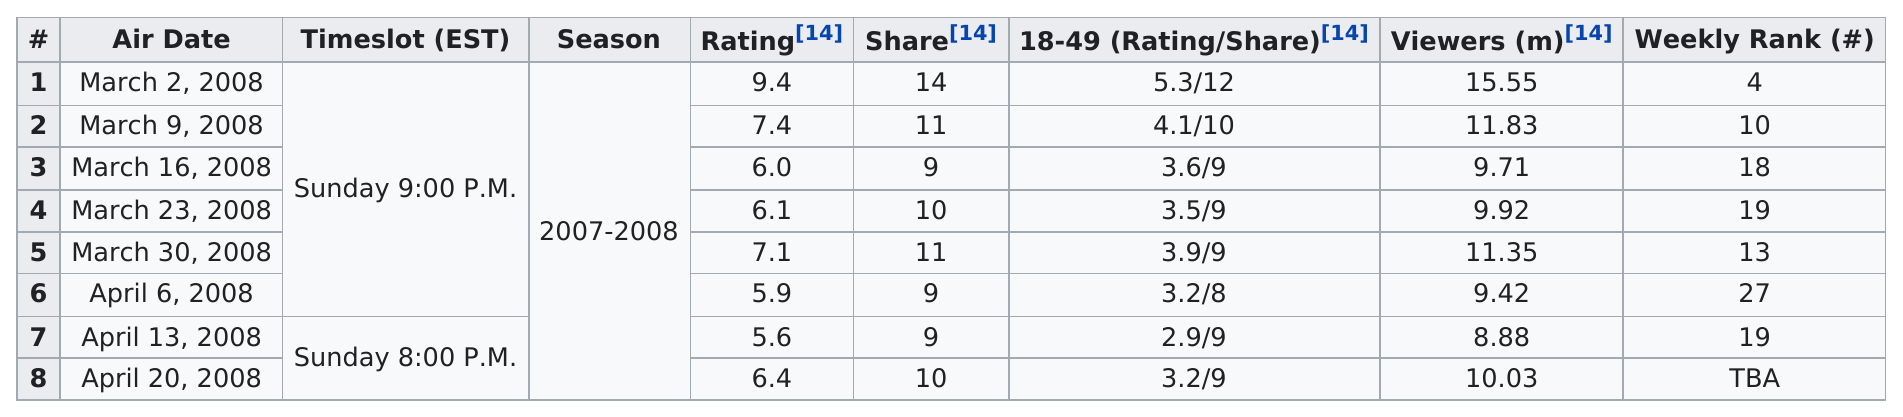Point out several critical features in this image. The episode with 11.35 million viewers was on March 30, 2008. For how long did the program air for, in days? The program aired for 8 days. Which television show had the highest rating among the options provided between 1 and? The least-rated air date was April 13, 2008. On March 2, 2008, the episode that had the highest rating was recorded. 